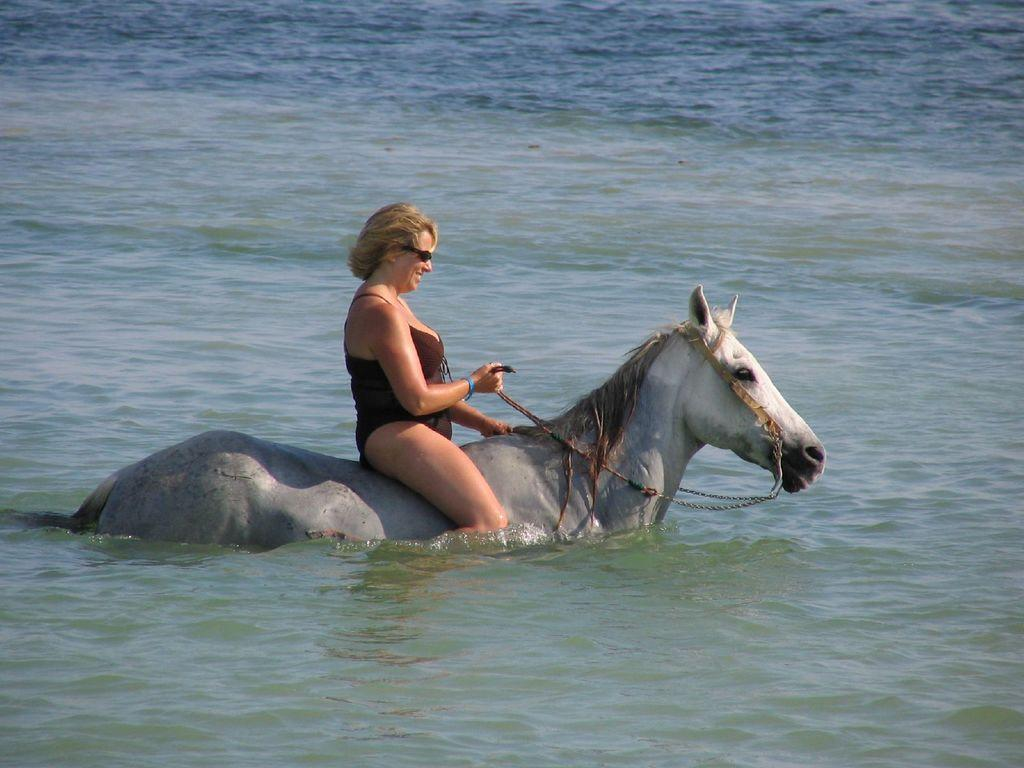What is the setting of the image? The image depicts an outside view. What activity is the person in the image engaged in? The person is riding a horse in the water. What is the person wearing while riding the horse? The person is wearing clothes. What accessory can be seen on the person's head? The person has sunglasses on her head. How many brothers does the person riding the horse have in the image? There is no information about the person's brothers in the image. 